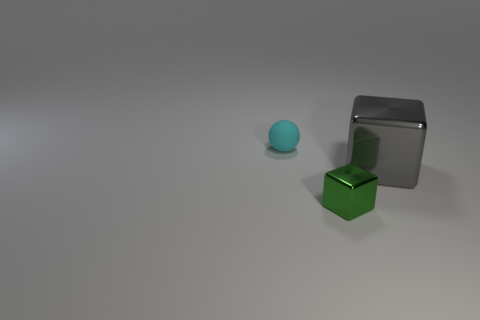Can you describe the relative positions of the objects in the image? Certainly! In the image, there are three objects positioned on a flat surface. To the left is the small blue sphere, the green cube is located center-right, and the gray matte cube is back right, slightly elevated and further away. 